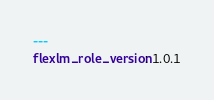Convert code to text. <code><loc_0><loc_0><loc_500><loc_500><_YAML_>---
flexlm_role_version: 1.0.1
</code> 